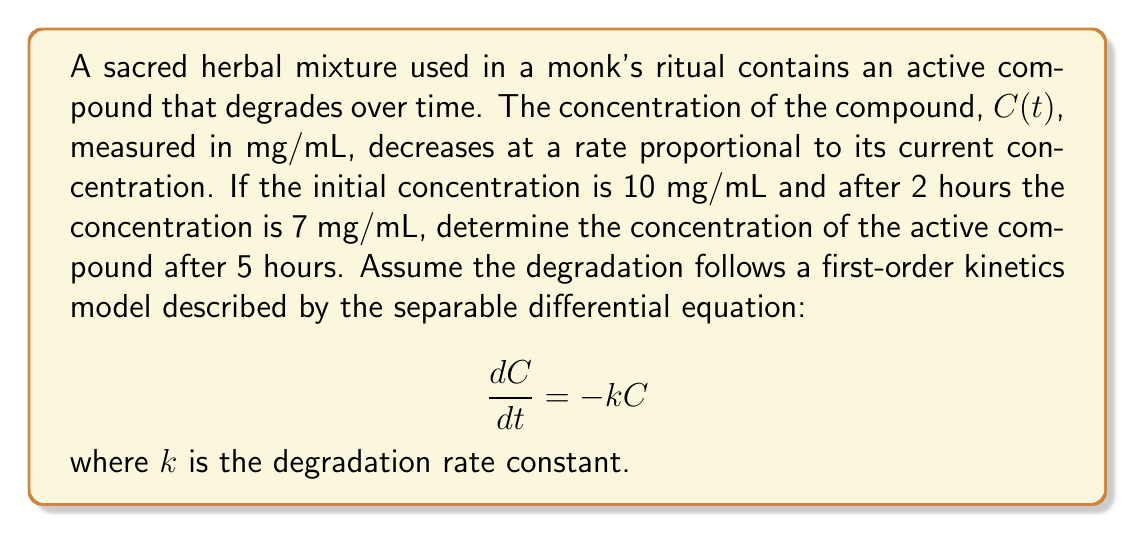Provide a solution to this math problem. To solve this problem, we'll follow these steps:

1) First, we need to solve the separable differential equation:
   $$\frac{dC}{dt} = -kC$$
   
   Separating variables:
   $$\frac{dC}{C} = -k dt$$
   
   Integrating both sides:
   $$\int \frac{dC}{C} = -k \int dt$$
   $$\ln|C| = -kt + A$$
   
   Where $A$ is the constant of integration.

2) Applying the exponential function to both sides:
   $$C = e^{-kt + A} = e^A e^{-kt} = C_0 e^{-kt}$$
   
   Where $C_0 = e^A$ is the initial concentration.

3) Now we can use the given information to find $k$:
   At $t=0$, $C=10$ mg/mL
   At $t=2$ hours, $C=7$ mg/mL
   
   Substituting into our equation:
   $$7 = 10e^{-2k}$$
   
   Solving for $k$:
   $$\ln(0.7) = -2k$$
   $$k = -\frac{\ln(0.7)}{2} \approx 0.1783 \text{ hour}^{-1}$$

4) Now that we have $k$, we can find the concentration at $t=5$ hours:
   $$C(5) = 10e^{-0.1783 \cdot 5}$$

5) Calculating this value:
   $$C(5) = 10e^{-0.8915} \approx 4.1013 \text{ mg/mL}$$
Answer: The concentration of the active compound after 5 hours is approximately 4.10 mg/mL. 